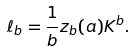<formula> <loc_0><loc_0><loc_500><loc_500>\ell _ { b } = \frac { 1 } { b } z _ { b } ( a ) K ^ { b } .</formula> 